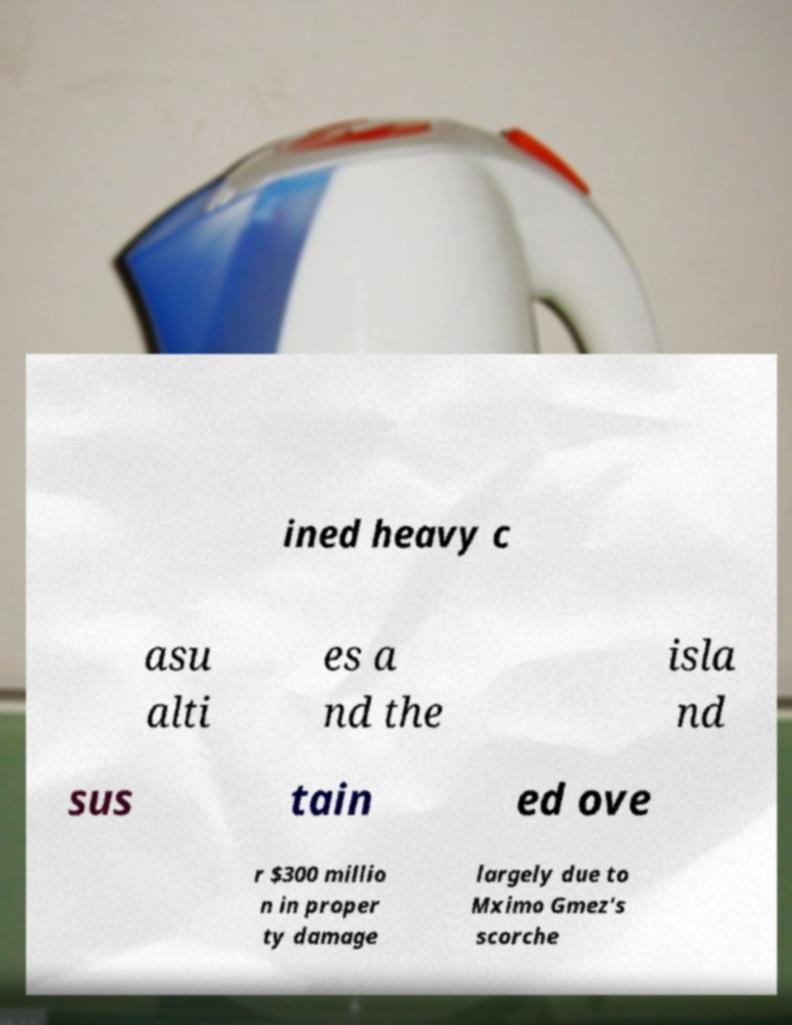What messages or text are displayed in this image? I need them in a readable, typed format. ined heavy c asu alti es a nd the isla nd sus tain ed ove r $300 millio n in proper ty damage largely due to Mximo Gmez's scorche 